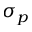Convert formula to latex. <formula><loc_0><loc_0><loc_500><loc_500>\sigma _ { p }</formula> 